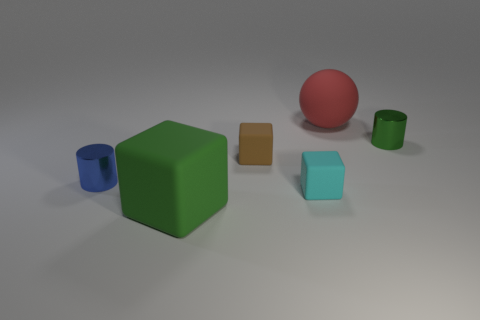There is a matte object that is behind the green shiny cylinder; is its size the same as the green object that is to the left of the tiny green cylinder?
Keep it short and to the point. Yes. Are there any cubes that have the same material as the big red thing?
Offer a very short reply. Yes. How many objects are tiny cylinders left of the small cyan thing or gray metallic cubes?
Keep it short and to the point. 1. Does the small cylinder that is on the left side of the green block have the same material as the cyan block?
Provide a succinct answer. No. Does the small cyan matte object have the same shape as the tiny green object?
Offer a terse response. No. How many small brown matte cubes are left of the tiny block that is behind the tiny blue metallic cylinder?
Provide a short and direct response. 0. There is a green thing that is the same shape as the blue thing; what is its material?
Ensure brevity in your answer.  Metal. There is a small metallic object on the left side of the big green rubber block; does it have the same color as the matte ball?
Keep it short and to the point. No. Is the material of the blue thing the same as the cylinder right of the big matte sphere?
Offer a terse response. Yes. There is a large object in front of the small brown matte object; what is its shape?
Your response must be concise. Cube. 